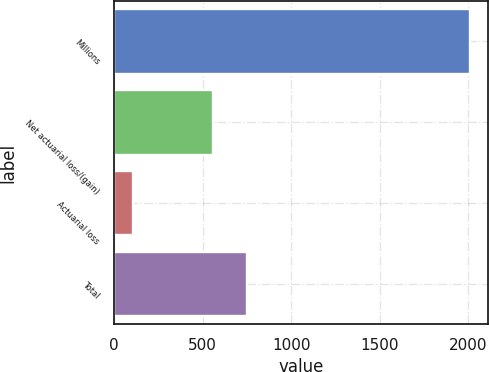Convert chart. <chart><loc_0><loc_0><loc_500><loc_500><bar_chart><fcel>Millions<fcel>Net actuarial loss/(gain)<fcel>Actuarial loss<fcel>Total<nl><fcel>2013<fcel>561<fcel>106<fcel>751.7<nl></chart> 